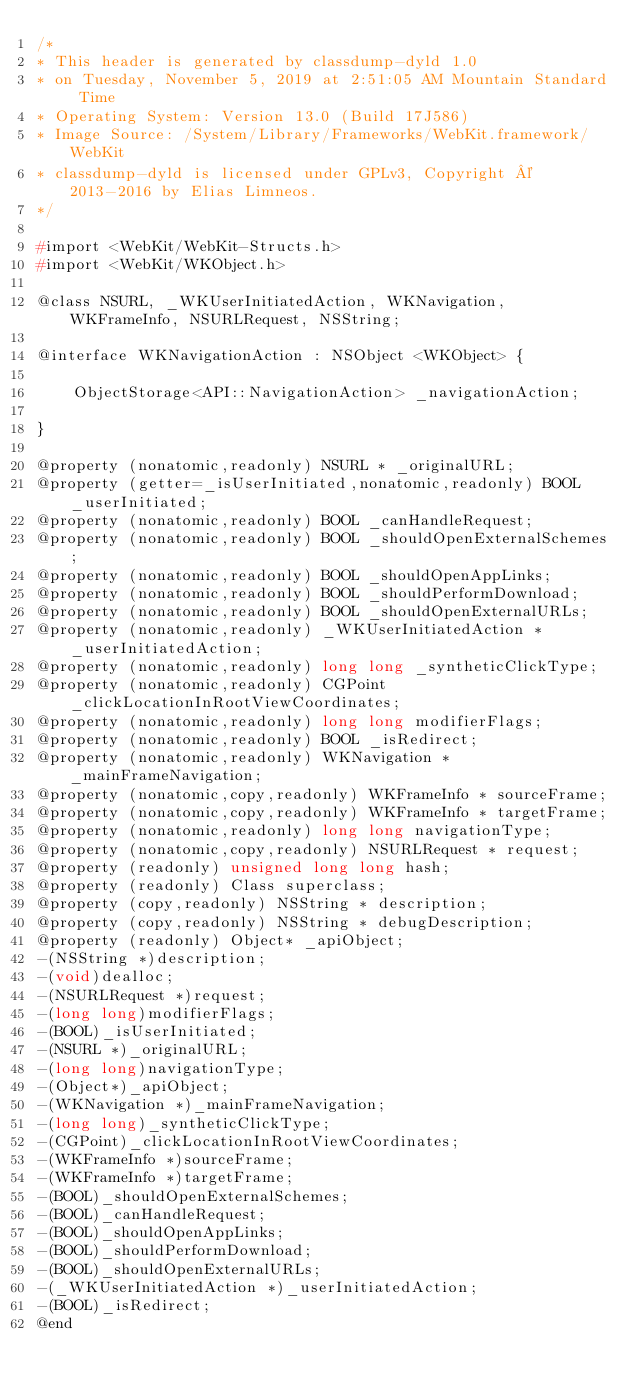<code> <loc_0><loc_0><loc_500><loc_500><_C_>/*
* This header is generated by classdump-dyld 1.0
* on Tuesday, November 5, 2019 at 2:51:05 AM Mountain Standard Time
* Operating System: Version 13.0 (Build 17J586)
* Image Source: /System/Library/Frameworks/WebKit.framework/WebKit
* classdump-dyld is licensed under GPLv3, Copyright © 2013-2016 by Elias Limneos.
*/

#import <WebKit/WebKit-Structs.h>
#import <WebKit/WKObject.h>

@class NSURL, _WKUserInitiatedAction, WKNavigation, WKFrameInfo, NSURLRequest, NSString;

@interface WKNavigationAction : NSObject <WKObject> {

	ObjectStorage<API::NavigationAction> _navigationAction;

}

@property (nonatomic,readonly) NSURL * _originalURL; 
@property (getter=_isUserInitiated,nonatomic,readonly) BOOL _userInitiated; 
@property (nonatomic,readonly) BOOL _canHandleRequest; 
@property (nonatomic,readonly) BOOL _shouldOpenExternalSchemes; 
@property (nonatomic,readonly) BOOL _shouldOpenAppLinks; 
@property (nonatomic,readonly) BOOL _shouldPerformDownload; 
@property (nonatomic,readonly) BOOL _shouldOpenExternalURLs; 
@property (nonatomic,readonly) _WKUserInitiatedAction * _userInitiatedAction; 
@property (nonatomic,readonly) long long _syntheticClickType; 
@property (nonatomic,readonly) CGPoint _clickLocationInRootViewCoordinates; 
@property (nonatomic,readonly) long long modifierFlags; 
@property (nonatomic,readonly) BOOL _isRedirect; 
@property (nonatomic,readonly) WKNavigation * _mainFrameNavigation; 
@property (nonatomic,copy,readonly) WKFrameInfo * sourceFrame; 
@property (nonatomic,copy,readonly) WKFrameInfo * targetFrame; 
@property (nonatomic,readonly) long long navigationType; 
@property (nonatomic,copy,readonly) NSURLRequest * request; 
@property (readonly) unsigned long long hash; 
@property (readonly) Class superclass; 
@property (copy,readonly) NSString * description; 
@property (copy,readonly) NSString * debugDescription; 
@property (readonly) Object* _apiObject; 
-(NSString *)description;
-(void)dealloc;
-(NSURLRequest *)request;
-(long long)modifierFlags;
-(BOOL)_isUserInitiated;
-(NSURL *)_originalURL;
-(long long)navigationType;
-(Object*)_apiObject;
-(WKNavigation *)_mainFrameNavigation;
-(long long)_syntheticClickType;
-(CGPoint)_clickLocationInRootViewCoordinates;
-(WKFrameInfo *)sourceFrame;
-(WKFrameInfo *)targetFrame;
-(BOOL)_shouldOpenExternalSchemes;
-(BOOL)_canHandleRequest;
-(BOOL)_shouldOpenAppLinks;
-(BOOL)_shouldPerformDownload;
-(BOOL)_shouldOpenExternalURLs;
-(_WKUserInitiatedAction *)_userInitiatedAction;
-(BOOL)_isRedirect;
@end

</code> 